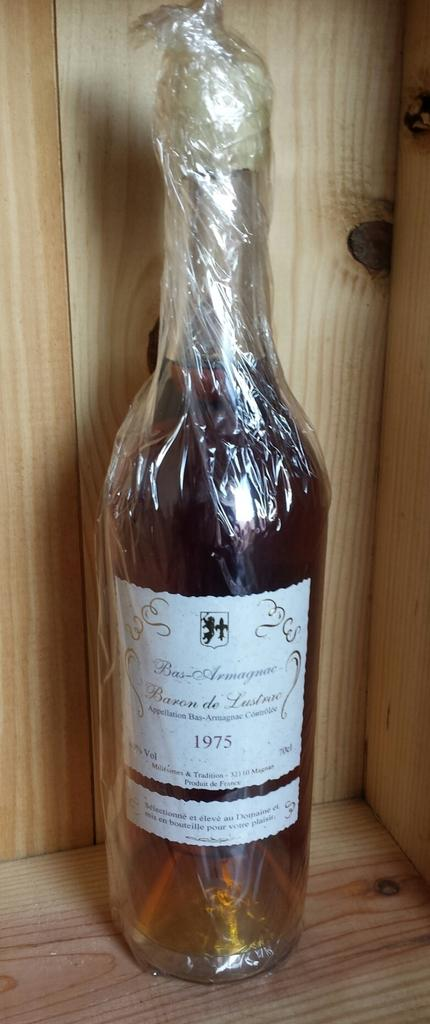What object is in the image that contains a drink? There is a glass bottle in the image that contains a drink. How is the drink protected or covered in the image? The drink is wrapped in a plastic cover. What type of label is on the bottle? The bottle has a paper label. What year is mentioned on the label? The year 1975 is mentioned on the label. What type of teeth whitening paste is advertised on the bottle in the image? There is no teeth whitening paste advertised on the bottle in the image; it contains a drink and has a label mentioning the year 1975. 